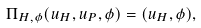Convert formula to latex. <formula><loc_0><loc_0><loc_500><loc_500>\Pi _ { H , \phi } ( u _ { H } , u _ { P } , \phi ) = ( u _ { H } , \phi ) ,</formula> 